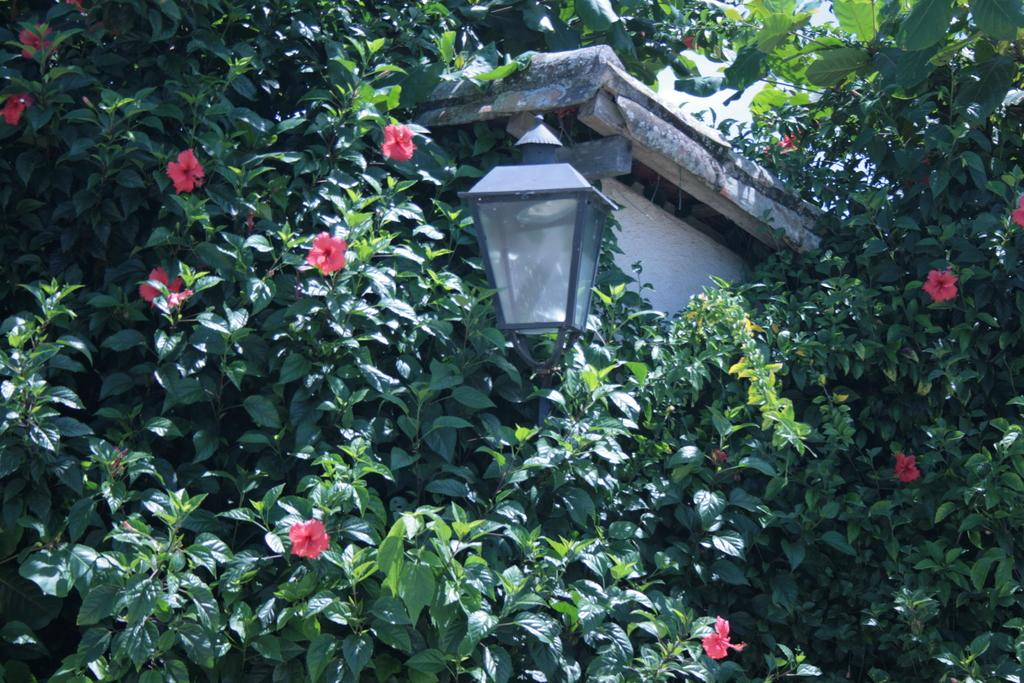What type of plants can be seen in the image? There are plants with green leaves in the image. What color are the flowers among the plants? There are red flowers in the image. What structure is present among the plants? There is a light pole in between the plants. What time of day is it in the image, and can you see a tiger walking in the background? The time of day is not mentioned in the image, and there is no tiger present in the image. 